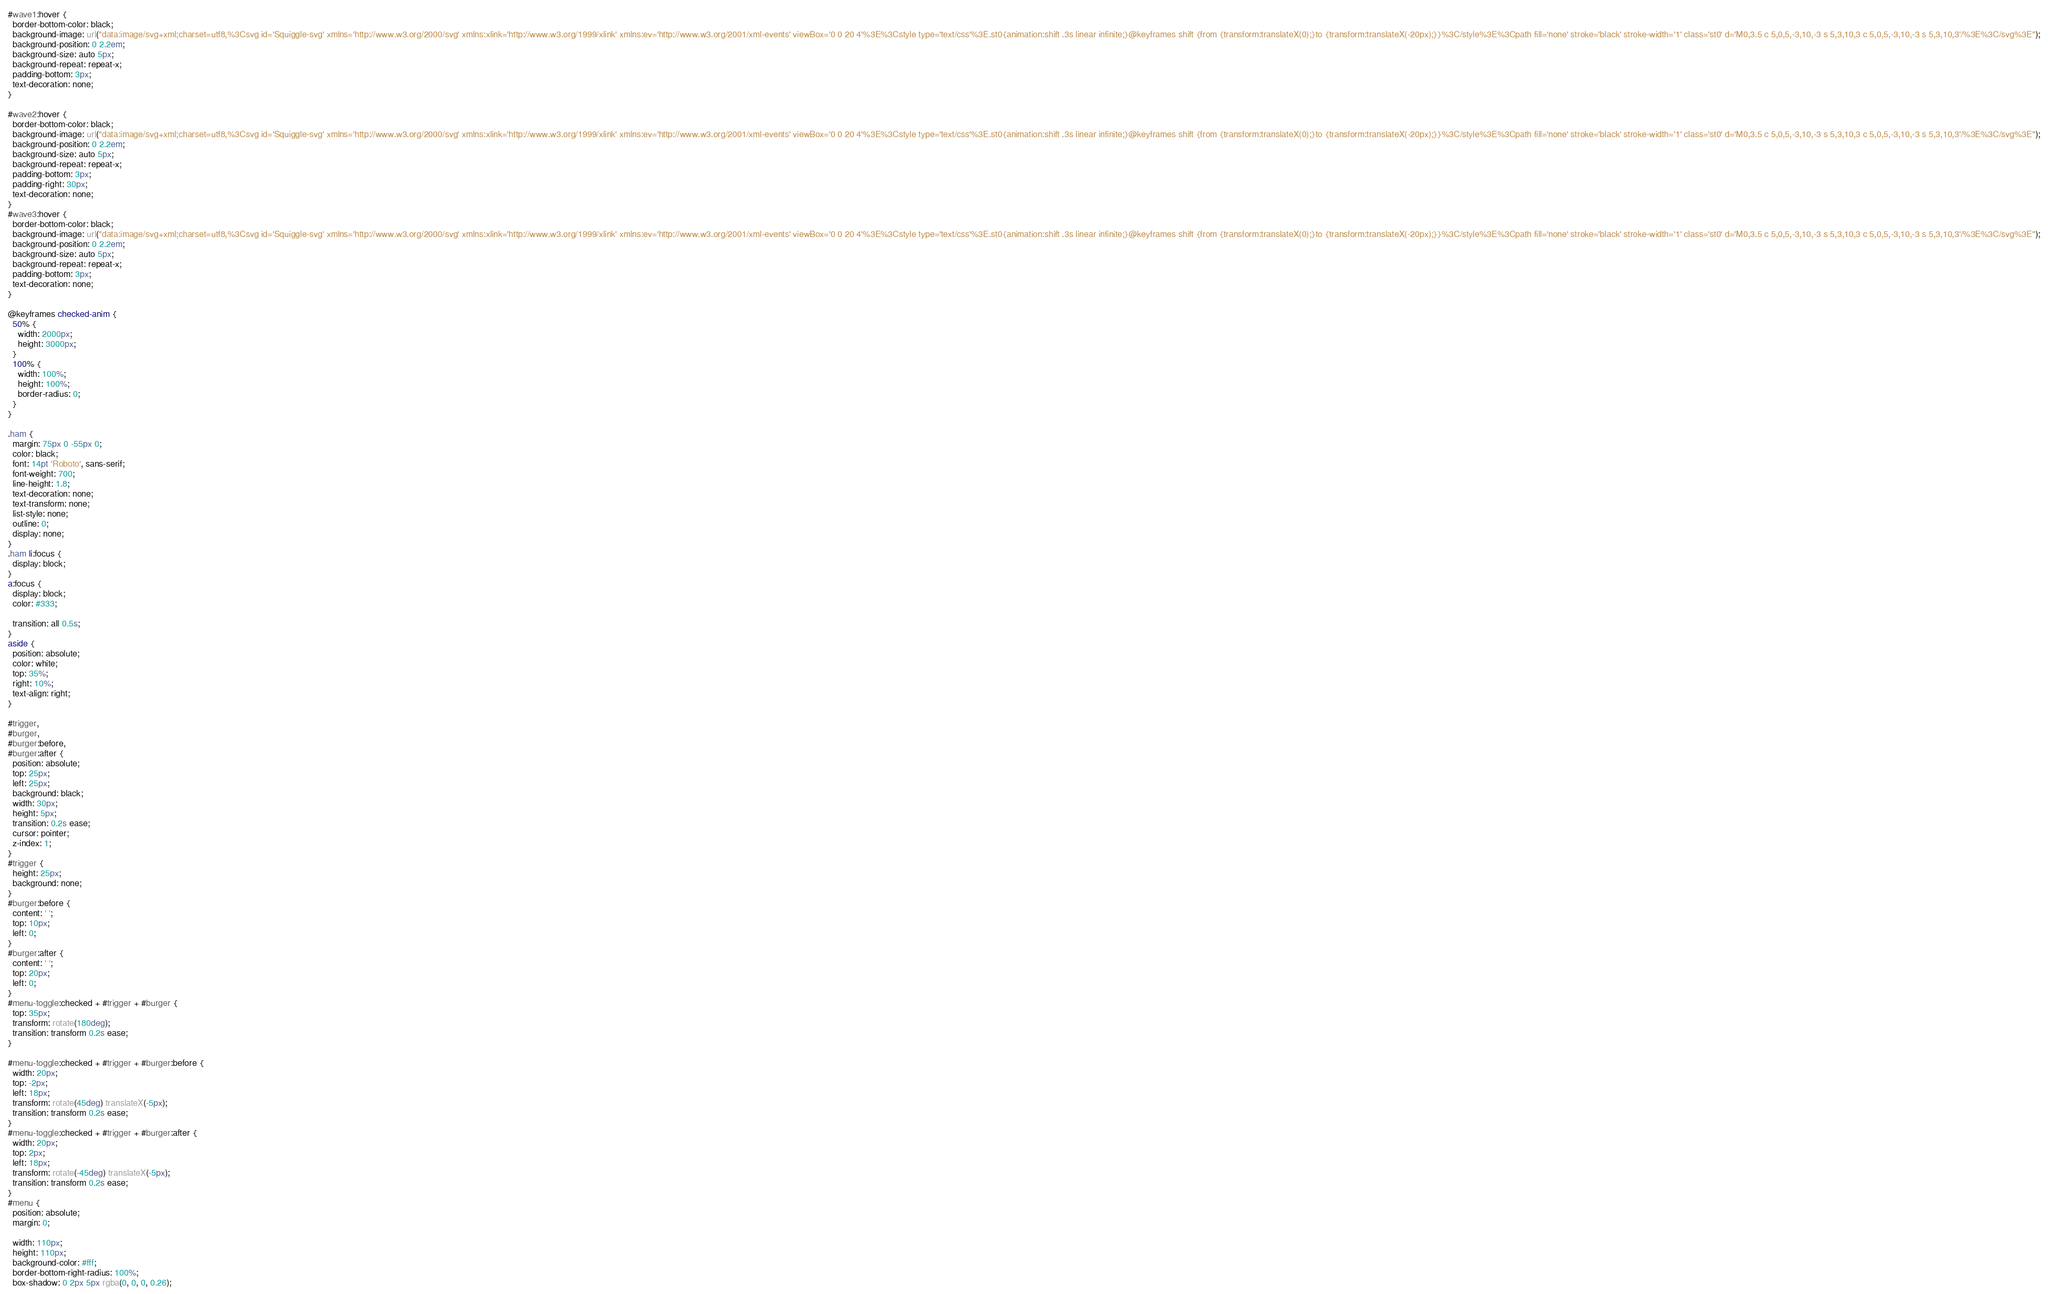<code> <loc_0><loc_0><loc_500><loc_500><_CSS_>#wave1:hover {
  border-bottom-color: black;
  background-image: url("data:image/svg+xml;charset=utf8,%3Csvg id='Squiggle-svg' xmlns='http://www.w3.org/2000/svg' xmlns:xlink='http://www.w3.org/1999/xlink' xmlns:ev='http://www.w3.org/2001/xml-events' viewBox='0 0 20 4'%3E%3Cstyle type='text/css'%3E.st0{animation:shift .3s linear infinite;}@keyframes shift {from {transform:translateX(0);}to {transform:translateX(-20px);}}%3C/style%3E%3Cpath fill='none' stroke='black' stroke-width='1' class='st0' d='M0,3.5 c 5,0,5,-3,10,-3 s 5,3,10,3 c 5,0,5,-3,10,-3 s 5,3,10,3'/%3E%3C/svg%3E");
  background-position: 0 2.2em;
  background-size: auto 5px;
  background-repeat: repeat-x;
  padding-bottom: 3px;
  text-decoration: none;
}

#wave2:hover {
  border-bottom-color: black;
  background-image: url("data:image/svg+xml;charset=utf8,%3Csvg id='Squiggle-svg' xmlns='http://www.w3.org/2000/svg' xmlns:xlink='http://www.w3.org/1999/xlink' xmlns:ev='http://www.w3.org/2001/xml-events' viewBox='0 0 20 4'%3E%3Cstyle type='text/css'%3E.st0{animation:shift .3s linear infinite;}@keyframes shift {from {transform:translateX(0);}to {transform:translateX(-20px);}}%3C/style%3E%3Cpath fill='none' stroke='black' stroke-width='1' class='st0' d='M0,3.5 c 5,0,5,-3,10,-3 s 5,3,10,3 c 5,0,5,-3,10,-3 s 5,3,10,3'/%3E%3C/svg%3E");
  background-position: 0 2.2em;
  background-size: auto 5px;
  background-repeat: repeat-x;
  padding-bottom: 3px;
  padding-right: 30px;
  text-decoration: none;
}
#wave3:hover {
  border-bottom-color: black;
  background-image: url("data:image/svg+xml;charset=utf8,%3Csvg id='Squiggle-svg' xmlns='http://www.w3.org/2000/svg' xmlns:xlink='http://www.w3.org/1999/xlink' xmlns:ev='http://www.w3.org/2001/xml-events' viewBox='0 0 20 4'%3E%3Cstyle type='text/css'%3E.st0{animation:shift .3s linear infinite;}@keyframes shift {from {transform:translateX(0);}to {transform:translateX(-20px);}}%3C/style%3E%3Cpath fill='none' stroke='black' stroke-width='1' class='st0' d='M0,3.5 c 5,0,5,-3,10,-3 s 5,3,10,3 c 5,0,5,-3,10,-3 s 5,3,10,3'/%3E%3C/svg%3E");
  background-position: 0 2.2em;
  background-size: auto 5px;
  background-repeat: repeat-x;
  padding-bottom: 3px;
  text-decoration: none;
}

@keyframes checked-anim {
  50% {
    width: 2000px;
    height: 3000px;
  }
  100% {
    width: 100%;
    height: 100%;
    border-radius: 0;
  }
}

.ham {
  margin: 75px 0 -55px 0;
  color: black;
  font: 14pt 'Roboto', sans-serif;
  font-weight: 700;
  line-height: 1.8;
  text-decoration: none;
  text-transform: none;
  list-style: none;
  outline: 0;
  display: none;
}
.ham li:focus {
  display: block;
}
a:focus {
  display: block;
  color: #333;

  transition: all 0.5s;
}
aside {
  position: absolute;
  color: white;
  top: 35%;
  right: 10%;
  text-align: right;
}

#trigger,
#burger,
#burger:before,
#burger:after {
  position: absolute;
  top: 25px;
  left: 25px;
  background: black;
  width: 30px;
  height: 5px;
  transition: 0.2s ease;
  cursor: pointer;
  z-index: 1;
}
#trigger {
  height: 25px;
  background: none;
}
#burger:before {
  content: ' ';
  top: 10px;
  left: 0;
}
#burger:after {
  content: ' ';
  top: 20px;
  left: 0;
}
#menu-toggle:checked + #trigger + #burger {
  top: 35px;
  transform: rotate(180deg);
  transition: transform 0.2s ease;
}

#menu-toggle:checked + #trigger + #burger:before {
  width: 20px;
  top: -2px;
  left: 18px;
  transform: rotate(45deg) translateX(-5px);
  transition: transform 0.2s ease;
}
#menu-toggle:checked + #trigger + #burger:after {
  width: 20px;
  top: 2px;
  left: 18px;
  transform: rotate(-45deg) translateX(-5px);
  transition: transform 0.2s ease;
}
#menu {
  position: absolute;
  margin: 0;

  width: 110px;
  height: 110px;
  background-color: #fff;
  border-bottom-right-radius: 100%;
  box-shadow: 0 2px 5px rgba(0, 0, 0, 0.26);</code> 